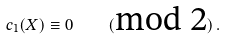<formula> <loc_0><loc_0><loc_500><loc_500>c _ { 1 } ( X ) \equiv 0 \quad ( \text {mod 2} ) \, .</formula> 